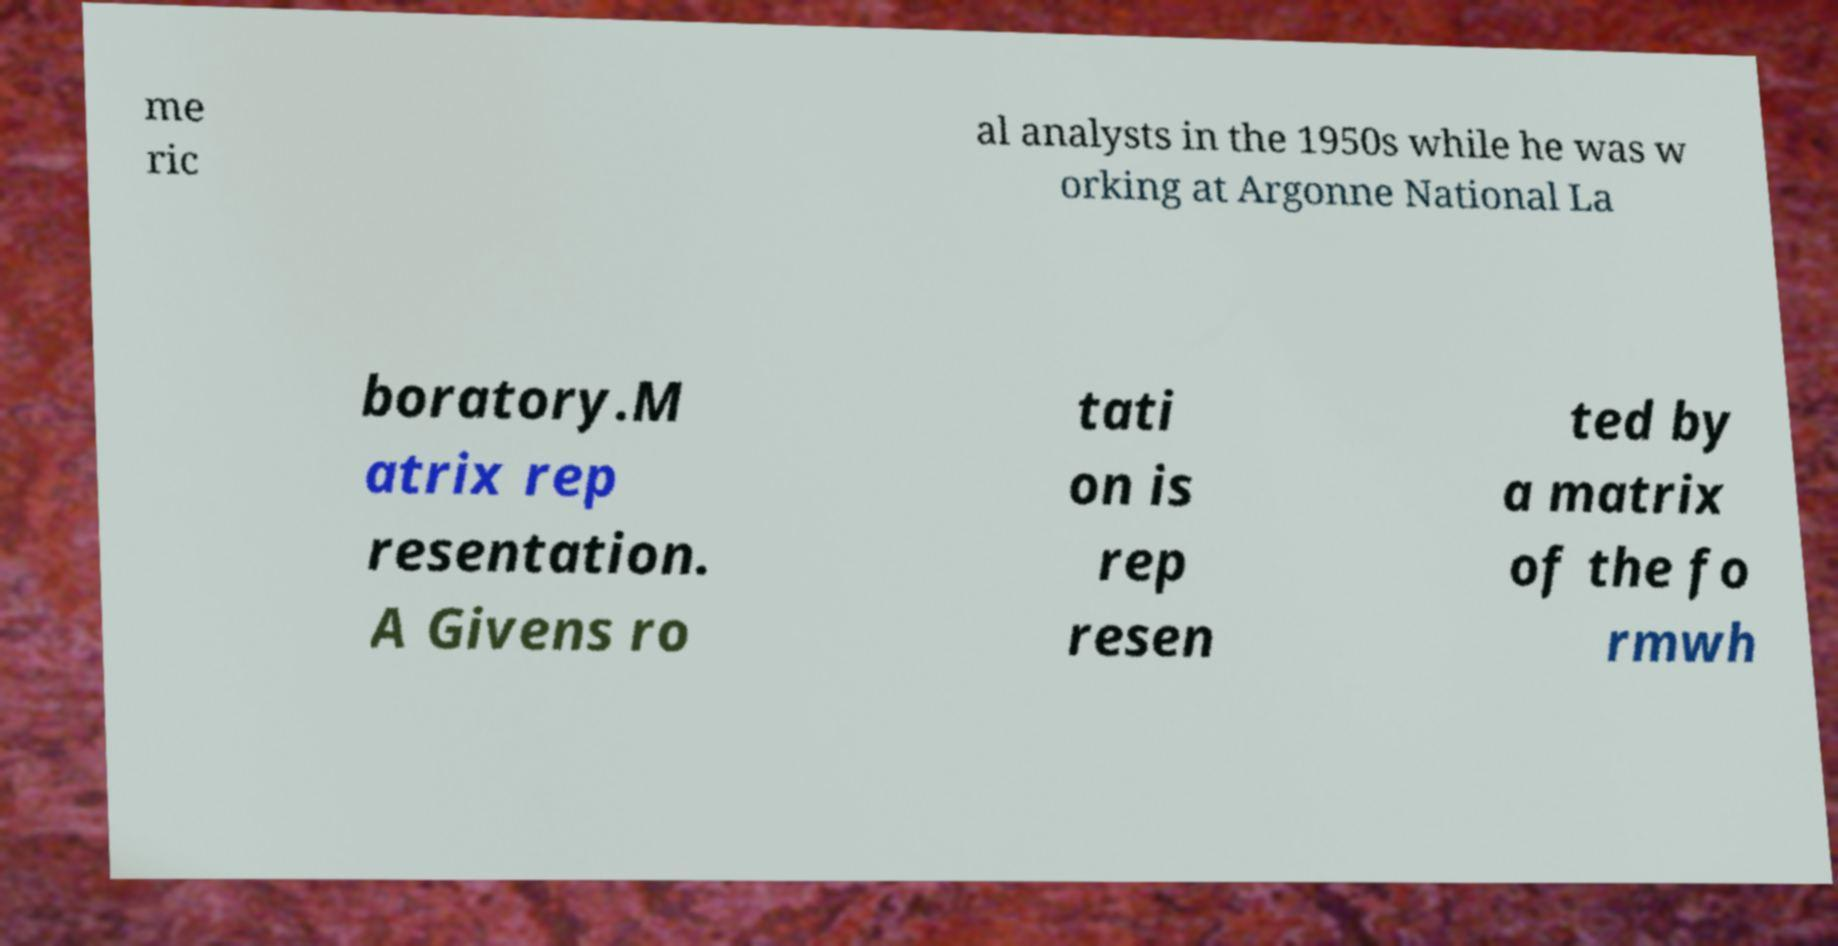For documentation purposes, I need the text within this image transcribed. Could you provide that? me ric al analysts in the 1950s while he was w orking at Argonne National La boratory.M atrix rep resentation. A Givens ro tati on is rep resen ted by a matrix of the fo rmwh 